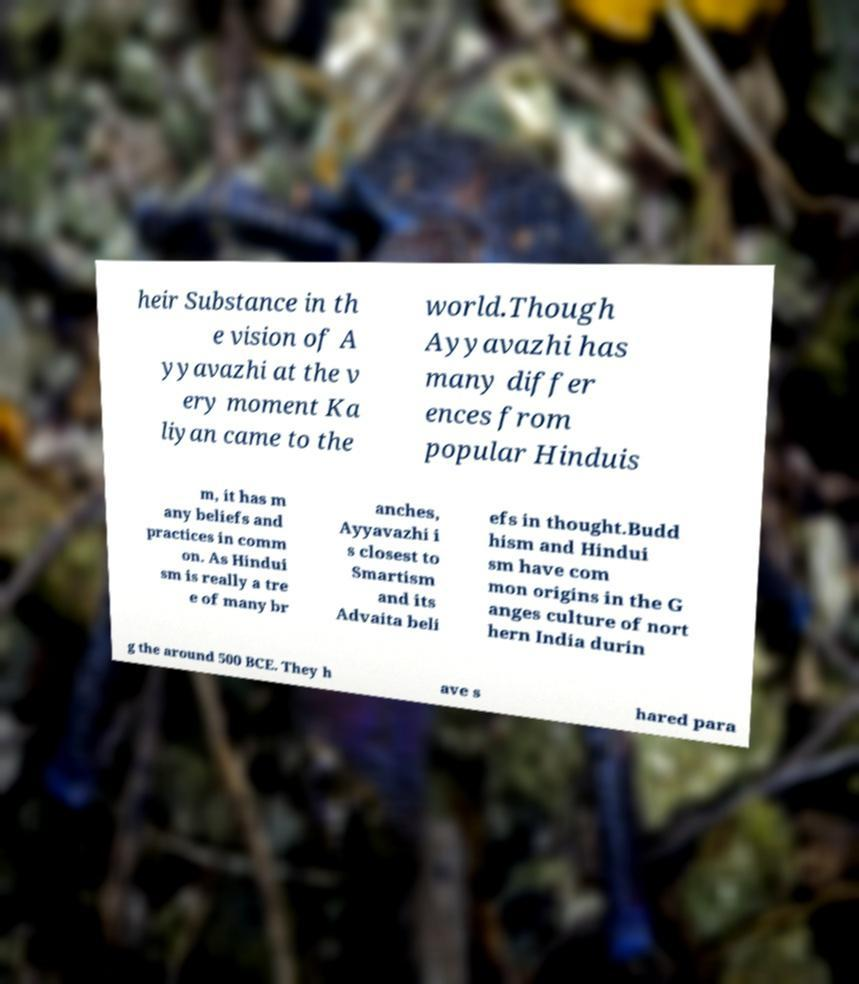What messages or text are displayed in this image? I need them in a readable, typed format. heir Substance in th e vision of A yyavazhi at the v ery moment Ka liyan came to the world.Though Ayyavazhi has many differ ences from popular Hinduis m, it has m any beliefs and practices in comm on. As Hindui sm is really a tre e of many br anches, Ayyavazhi i s closest to Smartism and its Advaita beli efs in thought.Budd hism and Hindui sm have com mon origins in the G anges culture of nort hern India durin g the around 500 BCE. They h ave s hared para 